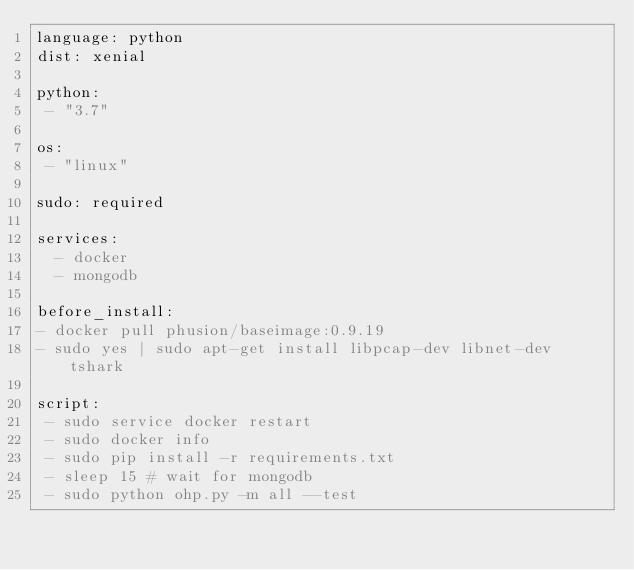Convert code to text. <code><loc_0><loc_0><loc_500><loc_500><_YAML_>language: python
dist: xenial

python:
 - "3.7"

os:
 - "linux"

sudo: required

services:
  - docker
  - mongodb

before_install:
- docker pull phusion/baseimage:0.9.19
- sudo yes | sudo apt-get install libpcap-dev libnet-dev tshark

script:
 - sudo service docker restart
 - sudo docker info
 - sudo pip install -r requirements.txt
 - sleep 15 # wait for mongodb
 - sudo python ohp.py -m all --test
</code> 